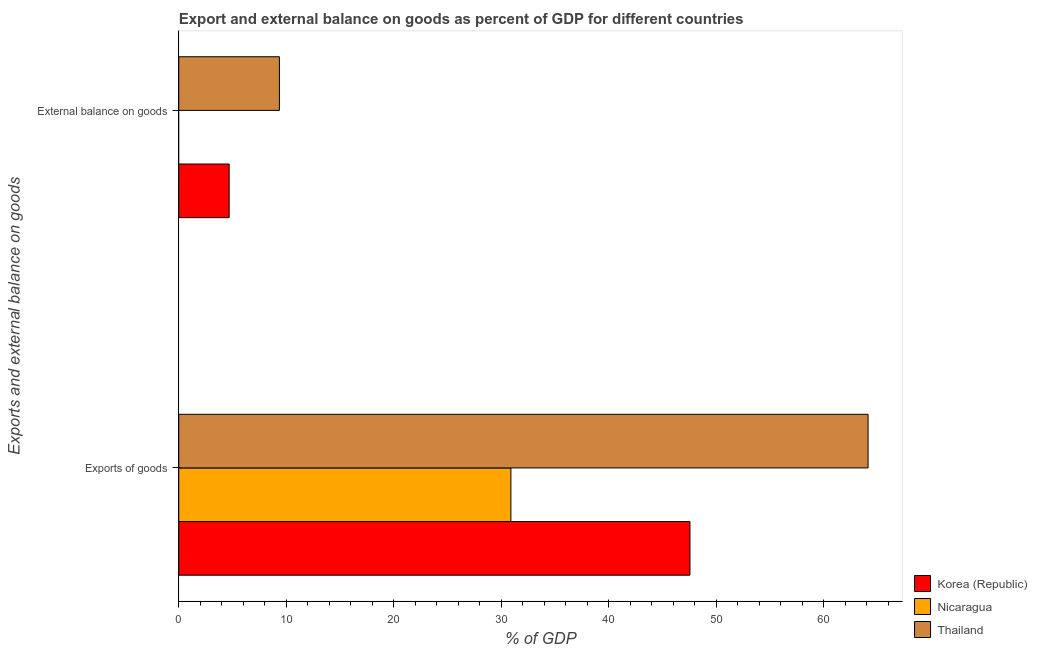How many different coloured bars are there?
Provide a short and direct response. 3. How many groups of bars are there?
Your answer should be compact. 2. How many bars are there on the 2nd tick from the bottom?
Offer a terse response. 2. What is the label of the 2nd group of bars from the top?
Your response must be concise. Exports of goods. What is the export of goods as percentage of gdp in Korea (Republic)?
Provide a succinct answer. 47.55. Across all countries, what is the maximum external balance on goods as percentage of gdp?
Offer a terse response. 9.36. Across all countries, what is the minimum export of goods as percentage of gdp?
Your answer should be compact. 30.89. In which country was the external balance on goods as percentage of gdp maximum?
Your answer should be very brief. Thailand. What is the total external balance on goods as percentage of gdp in the graph?
Keep it short and to the point. 14.05. What is the difference between the export of goods as percentage of gdp in Korea (Republic) and that in Nicaragua?
Your response must be concise. 16.66. What is the difference between the external balance on goods as percentage of gdp in Nicaragua and the export of goods as percentage of gdp in Korea (Republic)?
Your response must be concise. -47.55. What is the average external balance on goods as percentage of gdp per country?
Your answer should be compact. 4.68. What is the difference between the export of goods as percentage of gdp and external balance on goods as percentage of gdp in Korea (Republic)?
Provide a succinct answer. 42.86. What is the ratio of the external balance on goods as percentage of gdp in Korea (Republic) to that in Thailand?
Offer a very short reply. 0.5. Is the export of goods as percentage of gdp in Korea (Republic) less than that in Nicaragua?
Your answer should be compact. No. In how many countries, is the export of goods as percentage of gdp greater than the average export of goods as percentage of gdp taken over all countries?
Offer a very short reply. 2. How many bars are there?
Provide a short and direct response. 5. How many countries are there in the graph?
Give a very brief answer. 3. What is the difference between two consecutive major ticks on the X-axis?
Offer a terse response. 10. Does the graph contain any zero values?
Ensure brevity in your answer.  Yes. Where does the legend appear in the graph?
Your answer should be compact. Bottom right. What is the title of the graph?
Make the answer very short. Export and external balance on goods as percent of GDP for different countries. Does "World" appear as one of the legend labels in the graph?
Your response must be concise. No. What is the label or title of the X-axis?
Ensure brevity in your answer.  % of GDP. What is the label or title of the Y-axis?
Keep it short and to the point. Exports and external balance on goods. What is the % of GDP in Korea (Republic) in Exports of goods?
Your response must be concise. 47.55. What is the % of GDP of Nicaragua in Exports of goods?
Make the answer very short. 30.89. What is the % of GDP of Thailand in Exports of goods?
Offer a very short reply. 64.12. What is the % of GDP in Korea (Republic) in External balance on goods?
Keep it short and to the point. 4.69. What is the % of GDP in Thailand in External balance on goods?
Give a very brief answer. 9.36. Across all Exports and external balance on goods, what is the maximum % of GDP in Korea (Republic)?
Offer a very short reply. 47.55. Across all Exports and external balance on goods, what is the maximum % of GDP of Nicaragua?
Provide a short and direct response. 30.89. Across all Exports and external balance on goods, what is the maximum % of GDP of Thailand?
Provide a succinct answer. 64.12. Across all Exports and external balance on goods, what is the minimum % of GDP of Korea (Republic)?
Ensure brevity in your answer.  4.69. Across all Exports and external balance on goods, what is the minimum % of GDP in Thailand?
Your answer should be very brief. 9.36. What is the total % of GDP of Korea (Republic) in the graph?
Offer a very short reply. 52.24. What is the total % of GDP in Nicaragua in the graph?
Provide a short and direct response. 30.89. What is the total % of GDP in Thailand in the graph?
Offer a terse response. 73.48. What is the difference between the % of GDP of Korea (Republic) in Exports of goods and that in External balance on goods?
Keep it short and to the point. 42.86. What is the difference between the % of GDP in Thailand in Exports of goods and that in External balance on goods?
Your answer should be compact. 54.76. What is the difference between the % of GDP of Korea (Republic) in Exports of goods and the % of GDP of Thailand in External balance on goods?
Your response must be concise. 38.19. What is the difference between the % of GDP in Nicaragua in Exports of goods and the % of GDP in Thailand in External balance on goods?
Ensure brevity in your answer.  21.53. What is the average % of GDP of Korea (Republic) per Exports and external balance on goods?
Give a very brief answer. 26.12. What is the average % of GDP of Nicaragua per Exports and external balance on goods?
Keep it short and to the point. 15.45. What is the average % of GDP in Thailand per Exports and external balance on goods?
Keep it short and to the point. 36.74. What is the difference between the % of GDP of Korea (Republic) and % of GDP of Nicaragua in Exports of goods?
Your answer should be compact. 16.66. What is the difference between the % of GDP of Korea (Republic) and % of GDP of Thailand in Exports of goods?
Keep it short and to the point. -16.57. What is the difference between the % of GDP of Nicaragua and % of GDP of Thailand in Exports of goods?
Keep it short and to the point. -33.23. What is the difference between the % of GDP of Korea (Republic) and % of GDP of Thailand in External balance on goods?
Provide a succinct answer. -4.67. What is the ratio of the % of GDP of Korea (Republic) in Exports of goods to that in External balance on goods?
Your answer should be very brief. 10.15. What is the ratio of the % of GDP of Thailand in Exports of goods to that in External balance on goods?
Keep it short and to the point. 6.85. What is the difference between the highest and the second highest % of GDP in Korea (Republic)?
Your response must be concise. 42.86. What is the difference between the highest and the second highest % of GDP in Thailand?
Provide a succinct answer. 54.76. What is the difference between the highest and the lowest % of GDP in Korea (Republic)?
Provide a succinct answer. 42.86. What is the difference between the highest and the lowest % of GDP in Nicaragua?
Provide a short and direct response. 30.89. What is the difference between the highest and the lowest % of GDP in Thailand?
Make the answer very short. 54.76. 